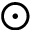Convert formula to latex. <formula><loc_0><loc_0><loc_500><loc_500>\odot</formula> 